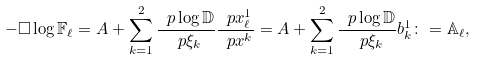<formula> <loc_0><loc_0><loc_500><loc_500>- \square \log \mathbb { F } _ { \ell } = A + \sum _ { k = 1 } ^ { 2 } \frac { \ p \log \mathbb { D } } { \ p \xi _ { k } } \frac { \ p x ^ { 1 } _ { \ell } } { \ p x ^ { k } } = A + \sum _ { k = 1 } ^ { 2 } \frac { \ p \log \mathbb { D } } { \ p \xi _ { k } } b ^ { 1 } _ { k } \colon = \mathbb { A } _ { \ell } ,</formula> 